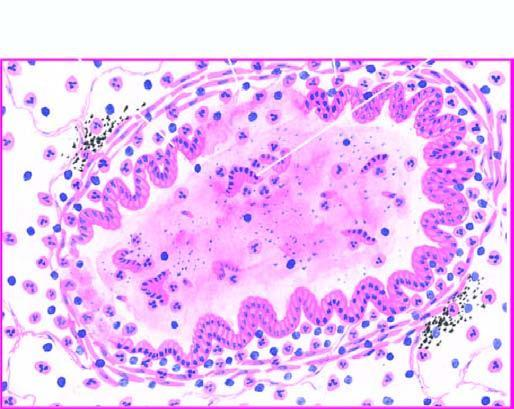s the bronchial wall thickened and infiltrated by acute and chronic inflammatory cells?
Answer the question using a single word or phrase. Yes 